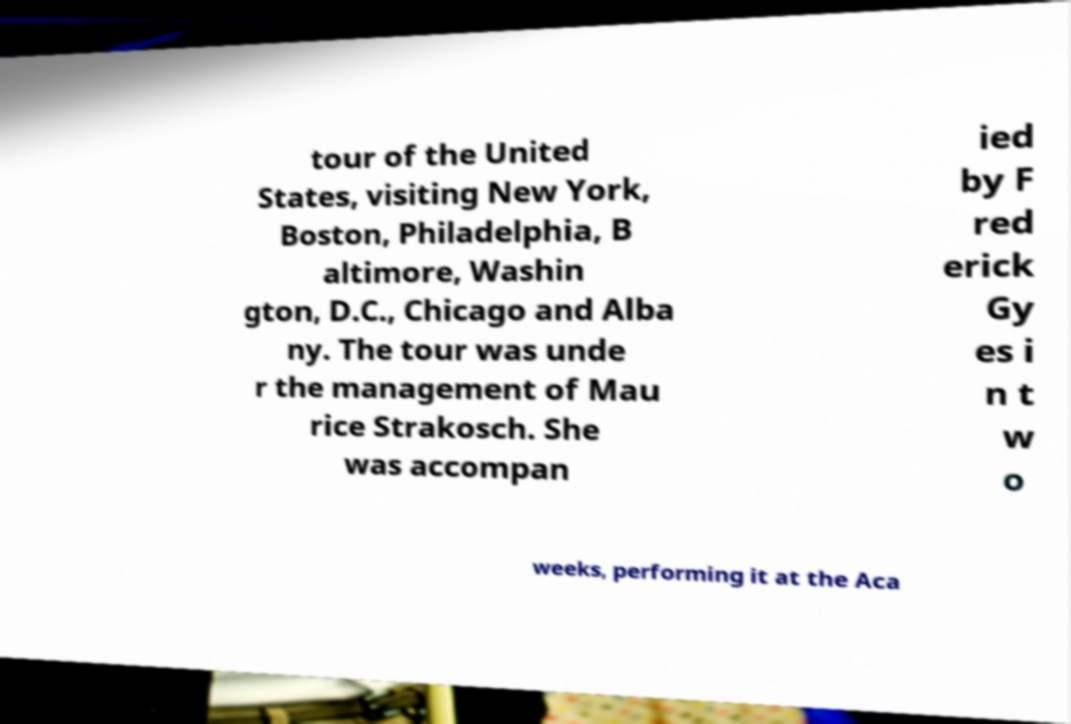Please identify and transcribe the text found in this image. tour of the United States, visiting New York, Boston, Philadelphia, B altimore, Washin gton, D.C., Chicago and Alba ny. The tour was unde r the management of Mau rice Strakosch. She was accompan ied by F red erick Gy es i n t w o weeks, performing it at the Aca 